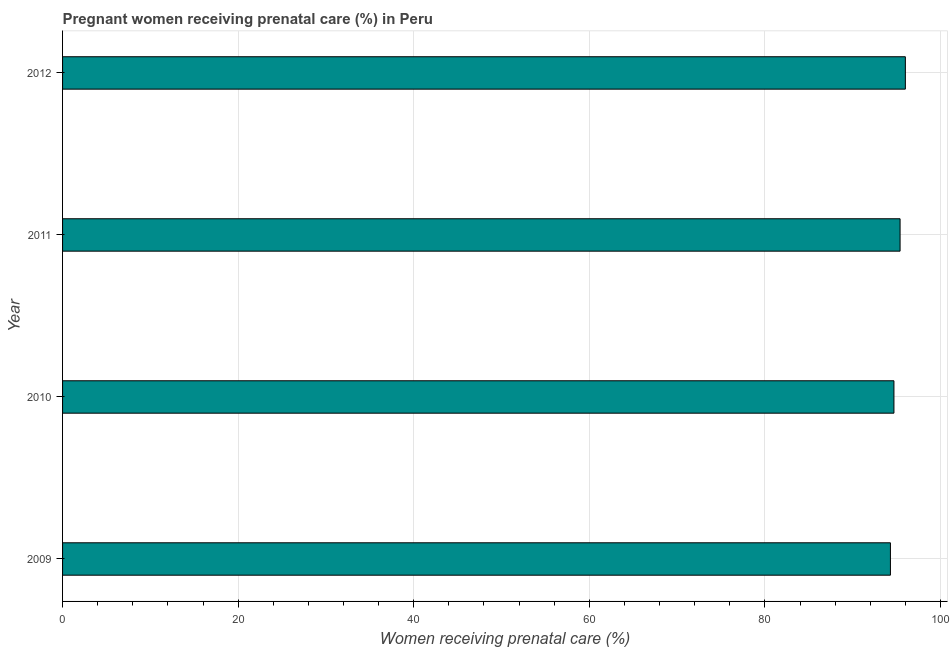Does the graph contain any zero values?
Make the answer very short. No. Does the graph contain grids?
Offer a terse response. Yes. What is the title of the graph?
Give a very brief answer. Pregnant women receiving prenatal care (%) in Peru. What is the label or title of the X-axis?
Keep it short and to the point. Women receiving prenatal care (%). What is the label or title of the Y-axis?
Your answer should be compact. Year. What is the percentage of pregnant women receiving prenatal care in 2010?
Your answer should be very brief. 94.7. Across all years, what is the maximum percentage of pregnant women receiving prenatal care?
Ensure brevity in your answer.  96. Across all years, what is the minimum percentage of pregnant women receiving prenatal care?
Ensure brevity in your answer.  94.3. In which year was the percentage of pregnant women receiving prenatal care minimum?
Your answer should be very brief. 2009. What is the sum of the percentage of pregnant women receiving prenatal care?
Give a very brief answer. 380.4. What is the average percentage of pregnant women receiving prenatal care per year?
Make the answer very short. 95.1. What is the median percentage of pregnant women receiving prenatal care?
Your response must be concise. 95.05. In how many years, is the percentage of pregnant women receiving prenatal care greater than 56 %?
Keep it short and to the point. 4. What is the ratio of the percentage of pregnant women receiving prenatal care in 2009 to that in 2010?
Give a very brief answer. 1. Is the percentage of pregnant women receiving prenatal care in 2009 less than that in 2010?
Keep it short and to the point. Yes. Is the difference between the percentage of pregnant women receiving prenatal care in 2010 and 2011 greater than the difference between any two years?
Make the answer very short. No. What is the difference between the highest and the second highest percentage of pregnant women receiving prenatal care?
Your answer should be very brief. 0.6. What is the difference between the highest and the lowest percentage of pregnant women receiving prenatal care?
Provide a short and direct response. 1.7. In how many years, is the percentage of pregnant women receiving prenatal care greater than the average percentage of pregnant women receiving prenatal care taken over all years?
Provide a short and direct response. 2. Are all the bars in the graph horizontal?
Offer a terse response. Yes. How many years are there in the graph?
Your answer should be compact. 4. What is the Women receiving prenatal care (%) in 2009?
Make the answer very short. 94.3. What is the Women receiving prenatal care (%) in 2010?
Your answer should be compact. 94.7. What is the Women receiving prenatal care (%) of 2011?
Your response must be concise. 95.4. What is the Women receiving prenatal care (%) in 2012?
Provide a succinct answer. 96. What is the difference between the Women receiving prenatal care (%) in 2009 and 2010?
Ensure brevity in your answer.  -0.4. What is the difference between the Women receiving prenatal care (%) in 2009 and 2011?
Your answer should be compact. -1.1. What is the difference between the Women receiving prenatal care (%) in 2009 and 2012?
Make the answer very short. -1.7. What is the ratio of the Women receiving prenatal care (%) in 2009 to that in 2010?
Make the answer very short. 1. 